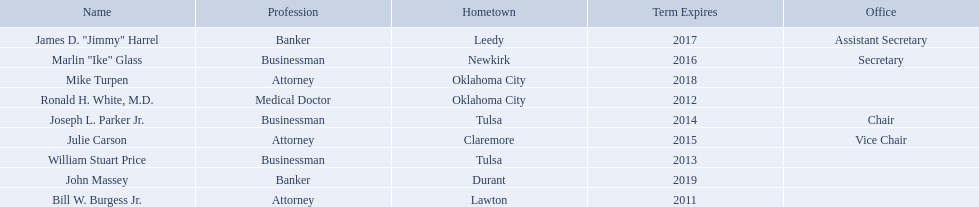What are the names of the oklahoma state regents for higher education? Bill W. Burgess Jr., Ronald H. White, M.D., William Stuart Price, Joseph L. Parker Jr., Julie Carson, Marlin "Ike" Glass, James D. "Jimmy" Harrel, Mike Turpen, John Massey. What is ronald h. white's hometown? Oklahoma City. Which other regent has the same hometown as above? Mike Turpen. Where is bill w. burgess jr. from? Lawton. Where is price and parker from? Tulsa. Who is from the same state as white? Mike Turpen. 